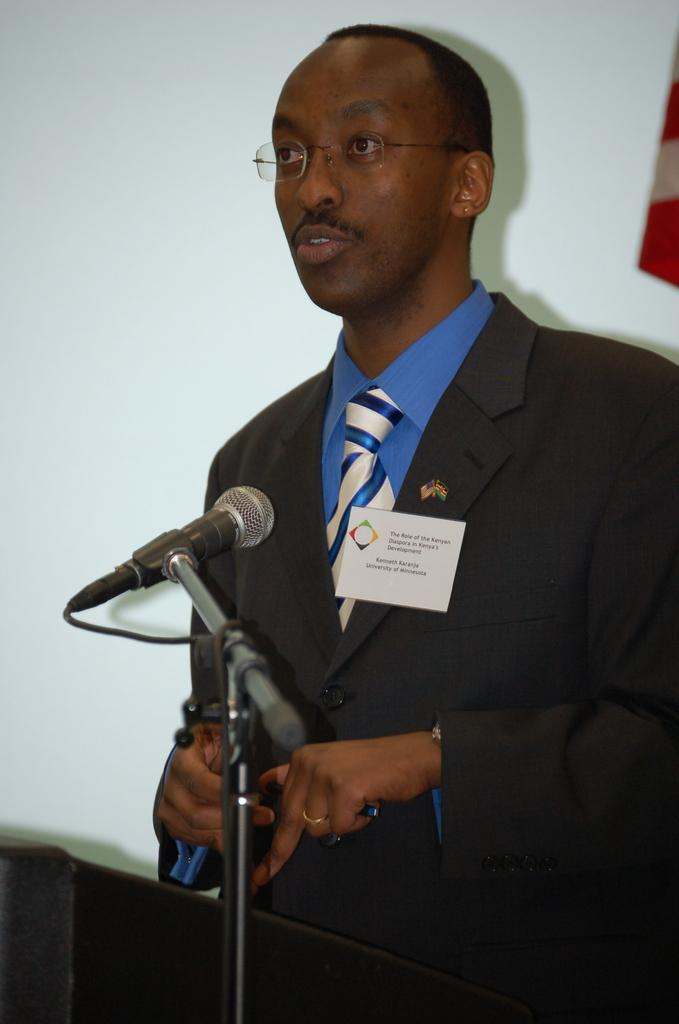What is the man in the image wearing? The man is wearing a tie, a shirt, and a coat. What object is present in the image that is typically used for amplifying sound? There is a microphone in the image. What can be seen in the background of the image? There is a wall in the background of the image. Where is the bed frame located in the image? There is no bed frame present in the image. What type of camp can be seen in the background of the image? There is no camp present in the image; it features a man, a microphone, and a wall in the background. 